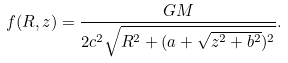Convert formula to latex. <formula><loc_0><loc_0><loc_500><loc_500>f ( R , z ) = \frac { G M } { 2 c ^ { 2 } \sqrt { R ^ { 2 } + ( a + \sqrt { z ^ { 2 } + b ^ { 2 } } ) ^ { 2 } } } .</formula> 